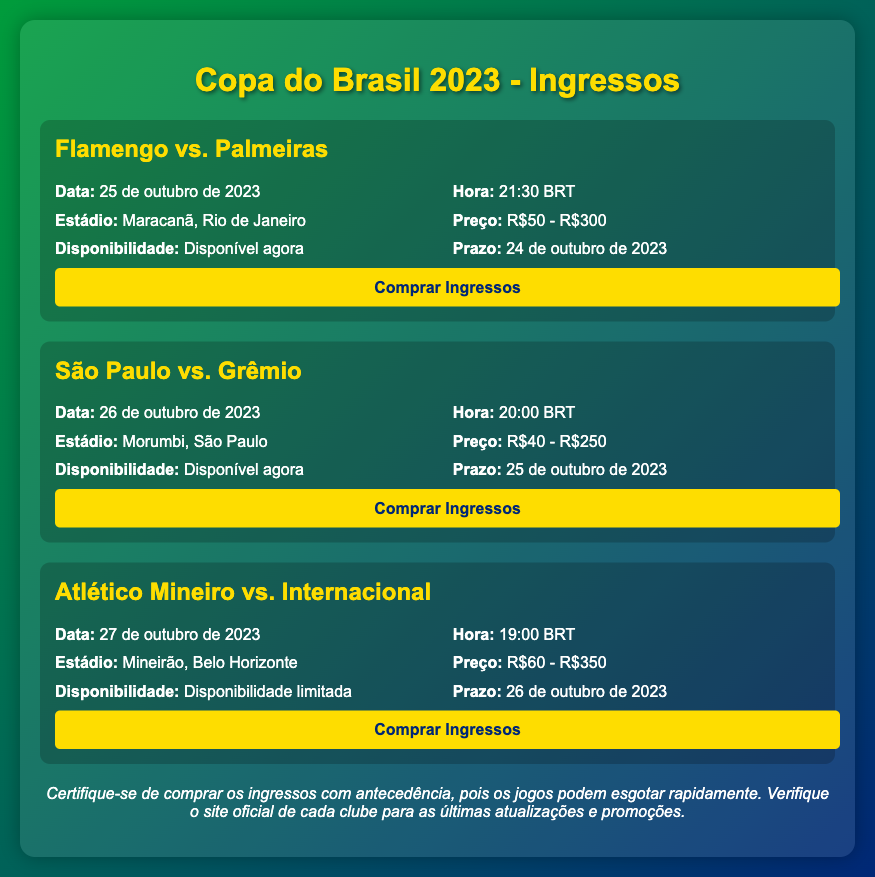what is the date of the Flamengo vs. Palmeiras match? The date is specifically mentioned in the match details section for Flamengo vs. Palmeiras.
Answer: 25 de outubro de 2023 what is the maximum ticket price for the São Paulo vs. Grêmio match? The maximum price is stated within the price detail for the match.
Answer: R$250 where will the Atlético Mineiro vs. Internacional match be held? The stadium information is provided in the match details for Atlético Mineiro vs. Internacional.
Answer: Mineirão, Belo Horizonte what time does the São Paulo vs. Grêmio match start? The starting time is listed in the details of the match.
Answer: 20:00 BRT what is the availability status for tickets to the Flamengo vs. Palmeiras match? This detail indicates if tickets are currently available, as stated in the match info.
Answer: Disponível agora what is the deadline for purchasing tickets for the Atlético Mineiro vs. Internacional match? The deadline is mentioned in the match information, signaling when tickets can no longer be purchased.
Answer: 26 de outubro de 2023 what is the price range for tickets to the Flamengo vs. Palmeiras match? The price range is detailed in the document for this match.
Answer: R$50 - R$300 how does the ticket availability for the Atlético Mineiro vs. Internacional match differ from the Flamengo vs. Palmeiras match? This requires comparing the availability notes of both matches to see the difference highlighted in the document.
Answer: Disponibilidade limitada vs. Disponível agora what is the note regarding ticket purchasing? A specific note is included to advise fans about ticket purchases, which summarizes essential advice.
Answer: Certifique-se de comprar os ingressos com antecedência, pois os jogos podem esgotar rapidamente 